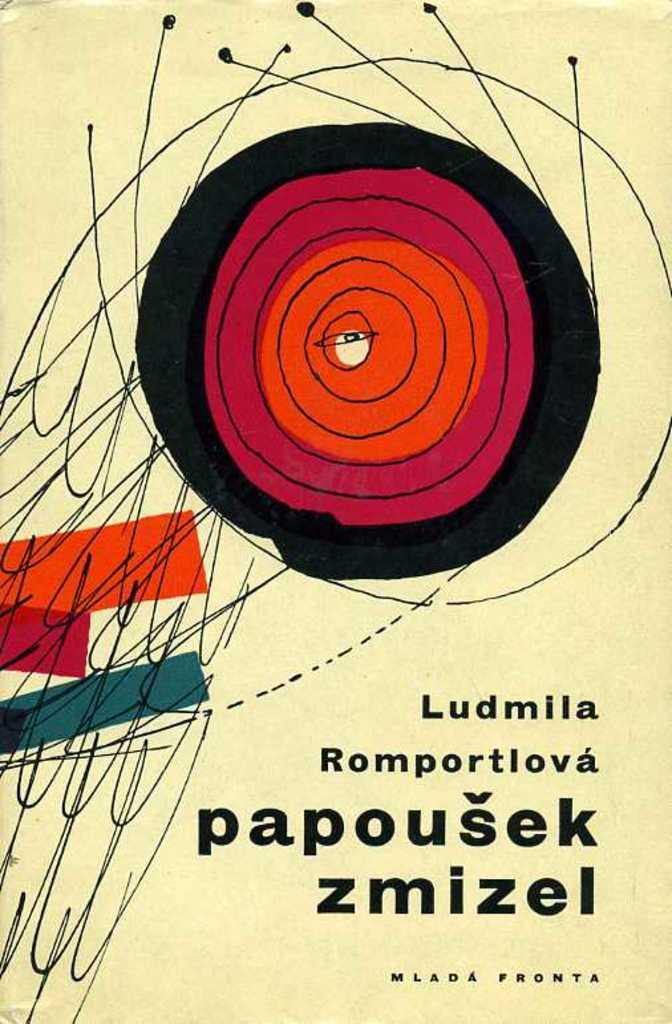<image>
Provide a brief description of the given image. The cover of a book titled Ludmila Romportlova rapousek zmizel. 